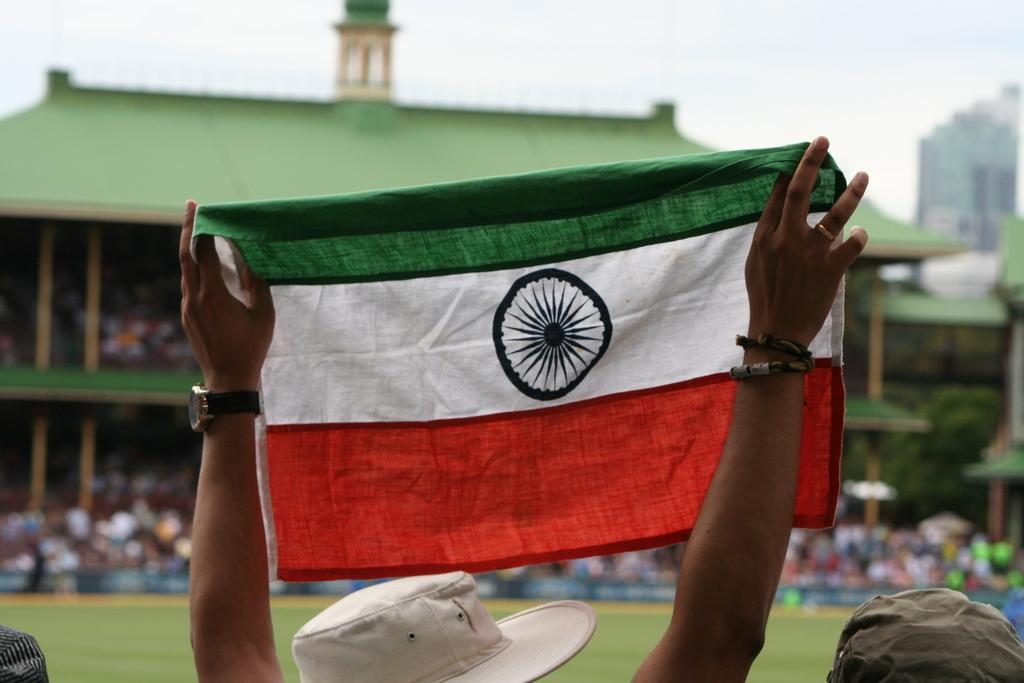What is the person at the bottom of the image doing? The person is standing at the bottom of the image and holding a flag. What can be seen in the background of the image? There are people standing and sitting in a stadium in front of the person holding the flag. What is visible at the top of the image? The sky is visible at the top of the image. How many quinces are being used as decorations in the image? There are no quinces present in the image. Is there a locket hanging from the flagpole in the image? There is no locket visible in the image. 